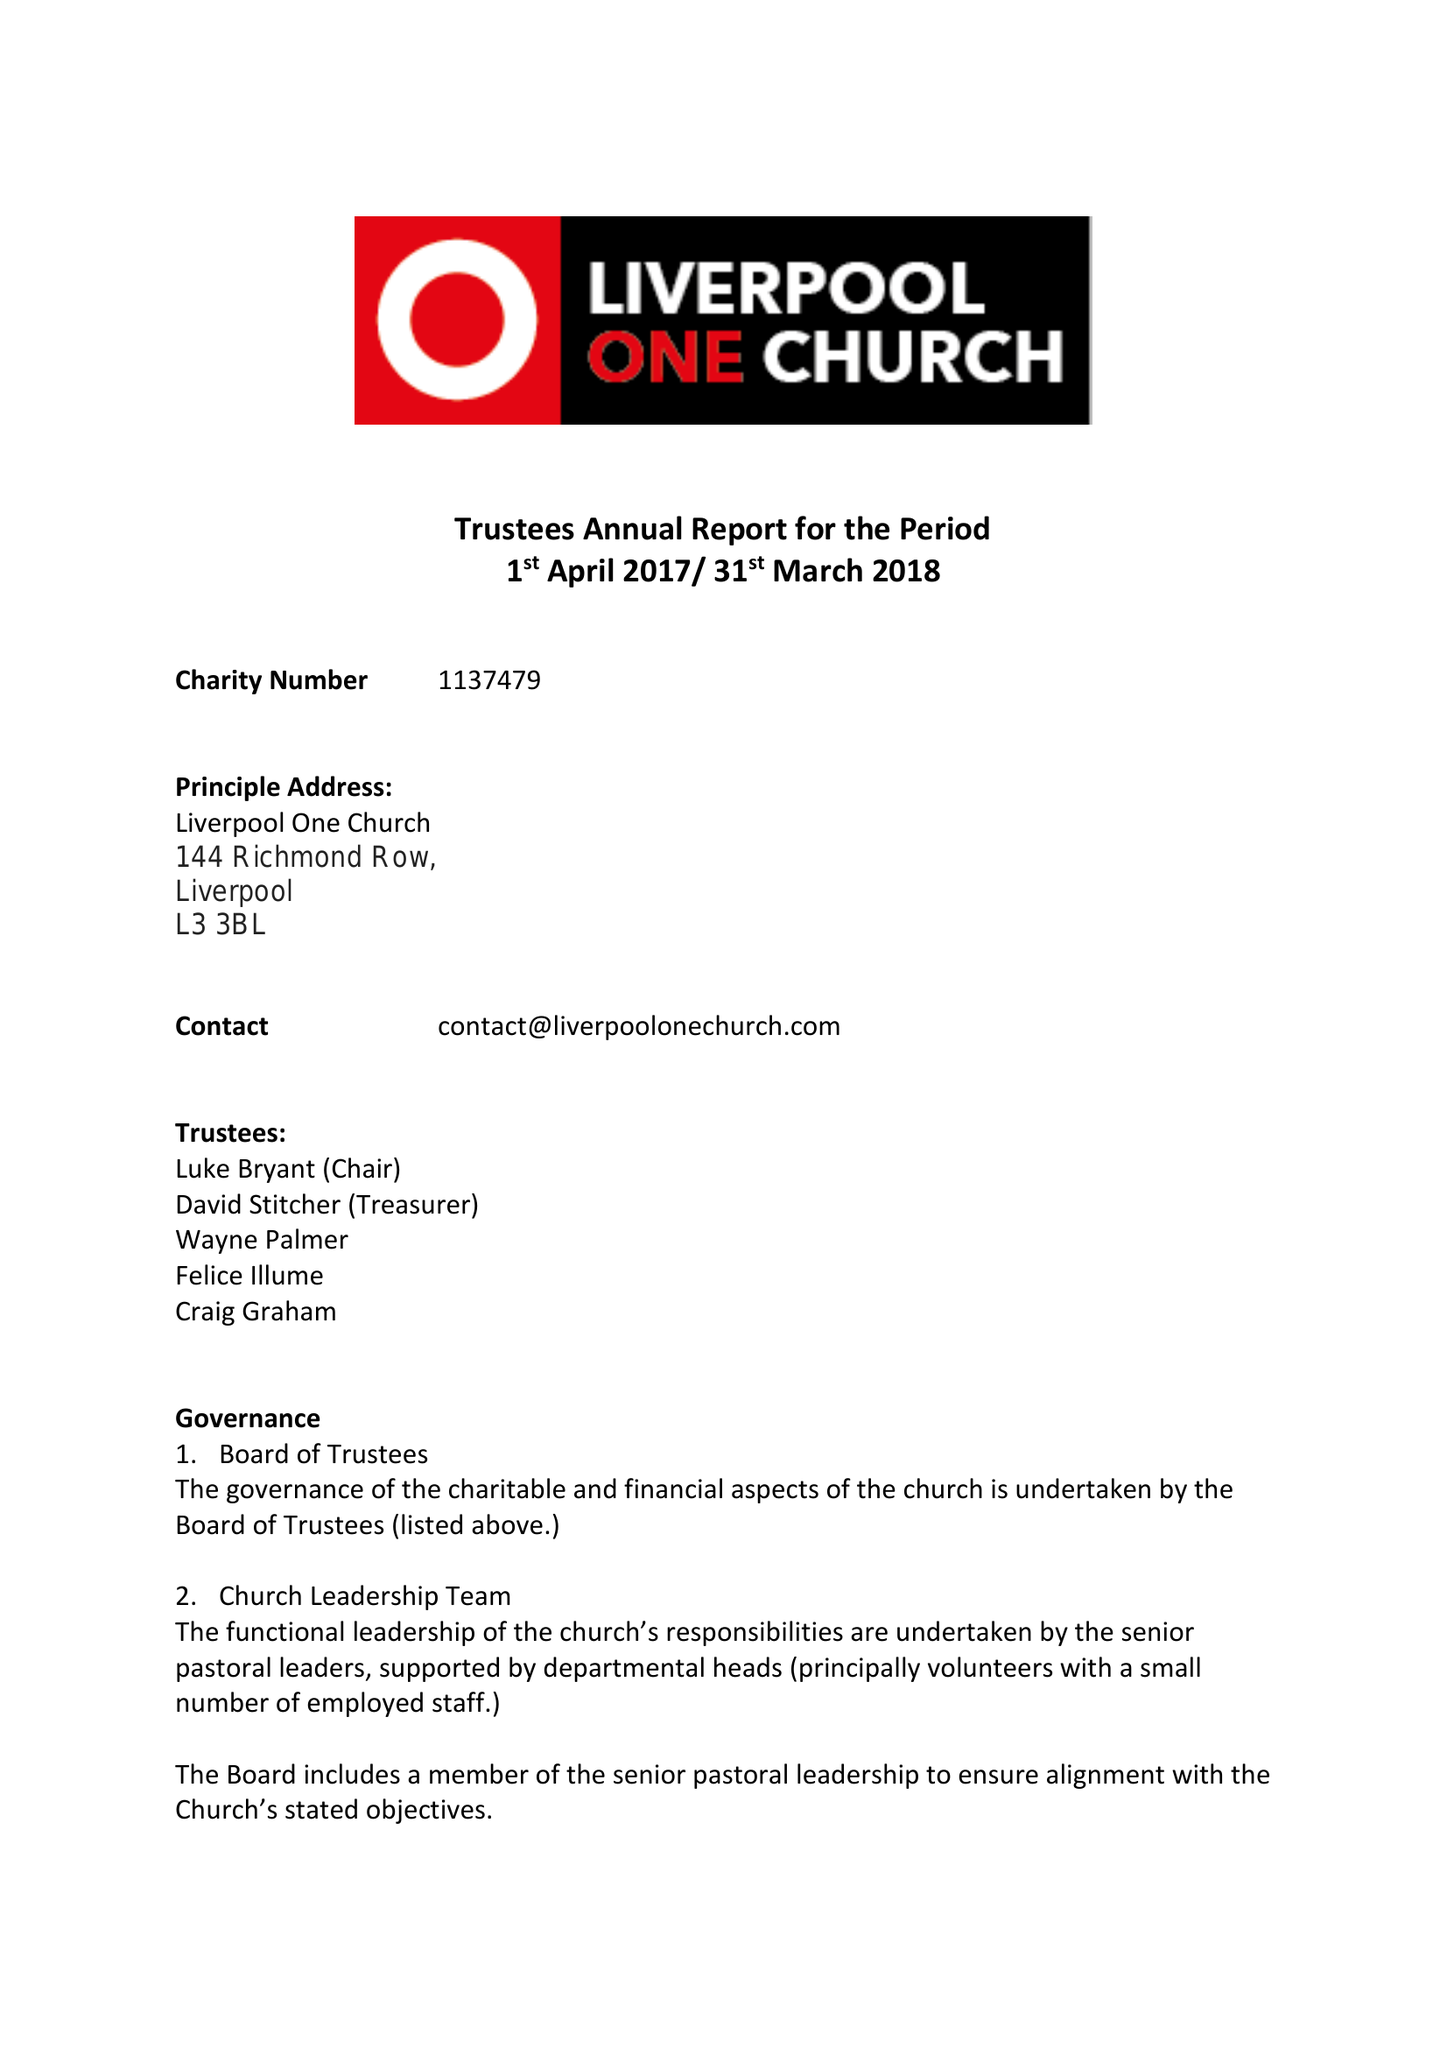What is the value for the report_date?
Answer the question using a single word or phrase. 2018-03-31 